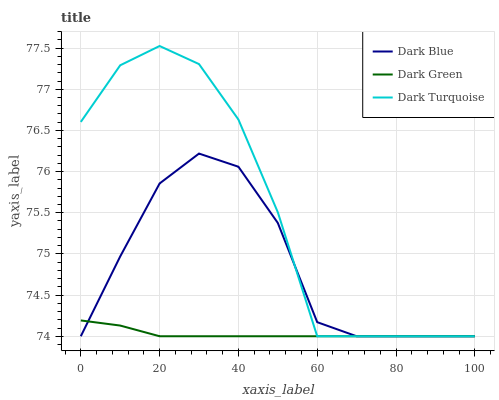Does Dark Green have the minimum area under the curve?
Answer yes or no. Yes. Does Dark Turquoise have the maximum area under the curve?
Answer yes or no. Yes. Does Dark Turquoise have the minimum area under the curve?
Answer yes or no. No. Does Dark Green have the maximum area under the curve?
Answer yes or no. No. Is Dark Green the smoothest?
Answer yes or no. Yes. Is Dark Turquoise the roughest?
Answer yes or no. Yes. Is Dark Turquoise the smoothest?
Answer yes or no. No. Is Dark Green the roughest?
Answer yes or no. No. Does Dark Blue have the lowest value?
Answer yes or no. Yes. Does Dark Turquoise have the highest value?
Answer yes or no. Yes. Does Dark Green have the highest value?
Answer yes or no. No. Does Dark Blue intersect Dark Turquoise?
Answer yes or no. Yes. Is Dark Blue less than Dark Turquoise?
Answer yes or no. No. Is Dark Blue greater than Dark Turquoise?
Answer yes or no. No. 